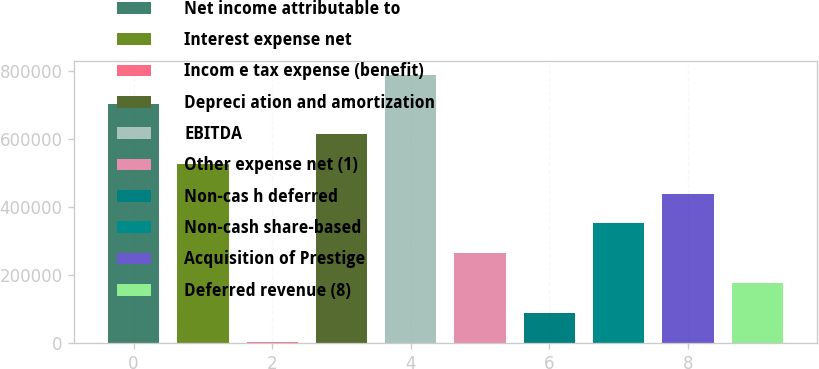<chart> <loc_0><loc_0><loc_500><loc_500><bar_chart><fcel>Net income attributable to<fcel>Interest expense net<fcel>Incom e tax expense (benefit)<fcel>Depreci ation and amortization<fcel>EBITDA<fcel>Other expense net (1)<fcel>Non-cas h deferred<fcel>Non-cash share-based<fcel>Acquisition of Prestige<fcel>Deferred revenue (8)<nl><fcel>702735<fcel>527618<fcel>2267<fcel>615176<fcel>790294<fcel>264942<fcel>89825.5<fcel>352501<fcel>440060<fcel>177384<nl></chart> 